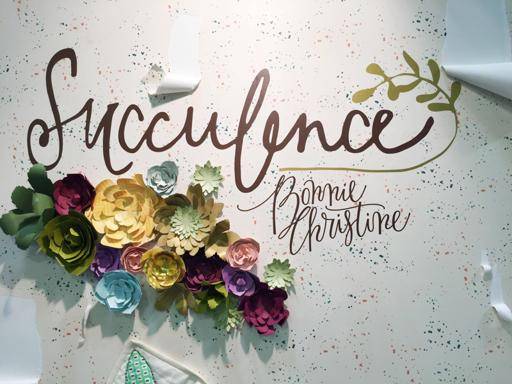How could someone make these types of paper flowers? These paper flowers can be made using colored paper and following various crafting techniques that involve cutting, folding, and layering to achieve the desired shapes and sizes. Tutorials on DIY crafts might offer guidance on creating these decorative elements. What materials are needed for such projects? To create such paper flowers, you would typically need materials like craft paper in various colors, scissors, glue, floral wire for stems, and possibly floral tape. Additional decorations such as glitter or spray paint can also be used to add unique touches. 